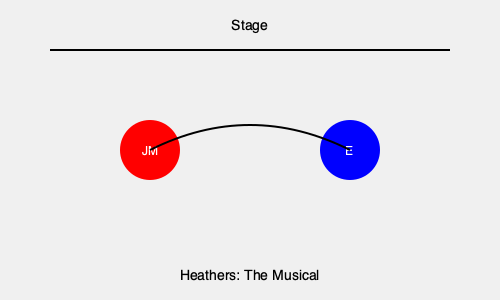Analyze the stage blocking diagram for a scene from "Heathers: The Musical" featuring Jamie Muscato. What does the curved arrow between the two characters suggest about their interaction, and how might this reflect Jamie's performance style in the role of JD? To answer this question, let's break down the stage blocking diagram and its implications:

1. Character positions:
   - JM (Jamie Muscato as JD) is represented by the red circle on the left.
   - E (likely representing Veronica or another character) is represented by the blue circle on the right.

2. Curved arrow:
   - The arrow moves from JM to E in a curved path.
   - This suggests a dynamic movement or interaction between the characters.

3. Implications of the curved path:
   - It indicates a non-direct approach, possibly implying subtlety or manipulation.
   - The curve could represent a gradual build-up in the interaction.
   - It might suggest a dance-like movement, fitting for a musical theatre production.

4. Jamie Muscato's performance style:
   - Known for his intense and charismatic performances, this blocking could allow Jamie to:
     a) Use the stage space dynamically, showcasing his physical presence.
     b) Build tension gradually as he approaches the other character.
     c) Demonstrate JD's manipulative nature through indirect movement.

5. Context of "Heathers: The Musical":
   - JD's character is complex and often manipulative, which aligns with this blocking choice.
   - The curved approach could be part of a song like "Freeze Your Brain" or "Our Love is God," where JD is trying to influence Veronica.

6. Theatrical significance:
   - This blocking creates visual interest and helps convey the subtext of the scene.
   - It allows for a more nuanced performance, giving Jamie room to showcase his acting and singing abilities simultaneously.

The curved arrow in this blocking diagram suggests a calculated, indirect interaction between JD and the other character, likely reflecting Jamie Muscato's ability to portray JD's complex and manipulative nature through both movement and vocal performance.
Answer: Indirect, calculated interaction showcasing JD's manipulative nature and Muscato's dynamic performance style. 